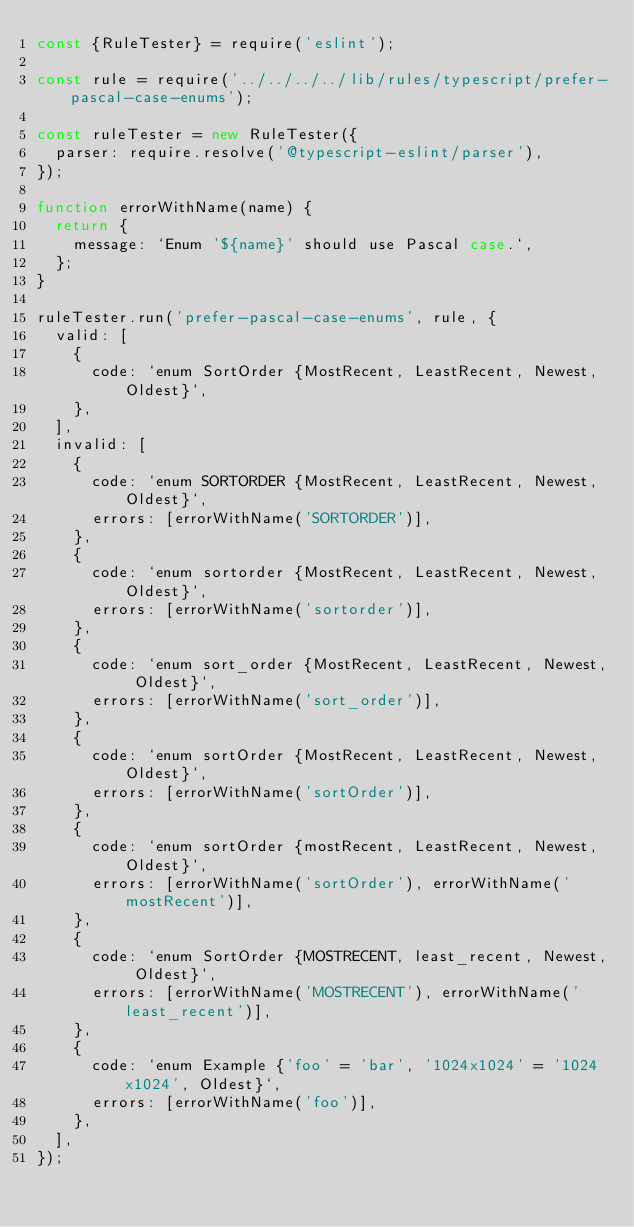<code> <loc_0><loc_0><loc_500><loc_500><_JavaScript_>const {RuleTester} = require('eslint');

const rule = require('../../../../lib/rules/typescript/prefer-pascal-case-enums');

const ruleTester = new RuleTester({
  parser: require.resolve('@typescript-eslint/parser'),
});

function errorWithName(name) {
  return {
    message: `Enum '${name}' should use Pascal case.`,
  };
}

ruleTester.run('prefer-pascal-case-enums', rule, {
  valid: [
    {
      code: `enum SortOrder {MostRecent, LeastRecent, Newest, Oldest}`,
    },
  ],
  invalid: [
    {
      code: `enum SORTORDER {MostRecent, LeastRecent, Newest, Oldest}`,
      errors: [errorWithName('SORTORDER')],
    },
    {
      code: `enum sortorder {MostRecent, LeastRecent, Newest, Oldest}`,
      errors: [errorWithName('sortorder')],
    },
    {
      code: `enum sort_order {MostRecent, LeastRecent, Newest, Oldest}`,
      errors: [errorWithName('sort_order')],
    },
    {
      code: `enum sortOrder {MostRecent, LeastRecent, Newest, Oldest}`,
      errors: [errorWithName('sortOrder')],
    },
    {
      code: `enum sortOrder {mostRecent, LeastRecent, Newest, Oldest}`,
      errors: [errorWithName('sortOrder'), errorWithName('mostRecent')],
    },
    {
      code: `enum SortOrder {MOSTRECENT, least_recent, Newest, Oldest}`,
      errors: [errorWithName('MOSTRECENT'), errorWithName('least_recent')],
    },
    {
      code: `enum Example {'foo' = 'bar', '1024x1024' = '1024x1024', Oldest}`,
      errors: [errorWithName('foo')],
    },
  ],
});
</code> 